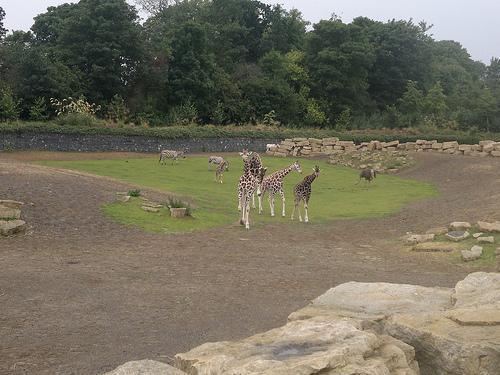How many giraffes are there?
Give a very brief answer. 5. How many different types of animals are there?
Give a very brief answer. 3. How many zebras are behind the giraffes?
Give a very brief answer. 3. 